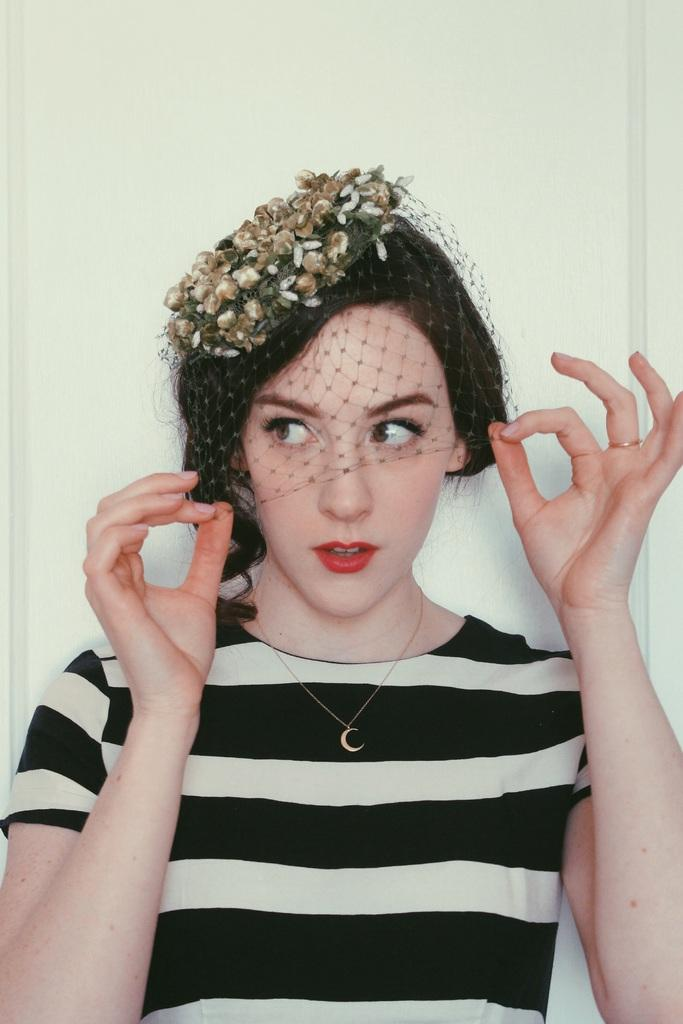Who is the main subject in the image? There is a woman in the center of the image. What is the woman wearing on her head? The woman is wearing a hat. What can be seen in the background of the image? There is a wall in the background of the image. What type of laborer is the woman in the image? There is no indication in the image that the woman is a laborer, so it cannot be determined from the picture. 